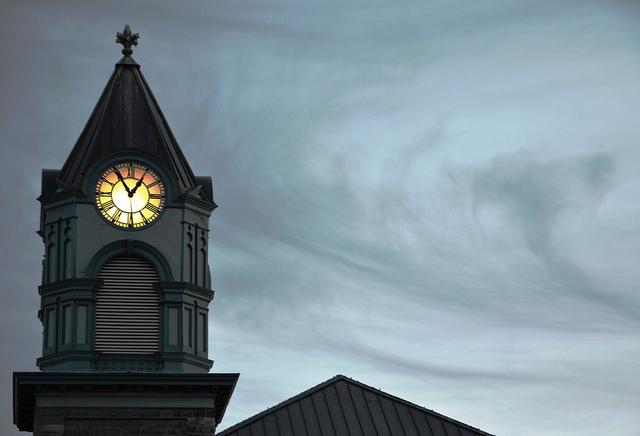Name the cloud formation in the background of this photo?
Give a very brief answer. Cumulus. What time is it?
Keep it brief. 12:55. Could this be a church?
Write a very short answer. Yes. 